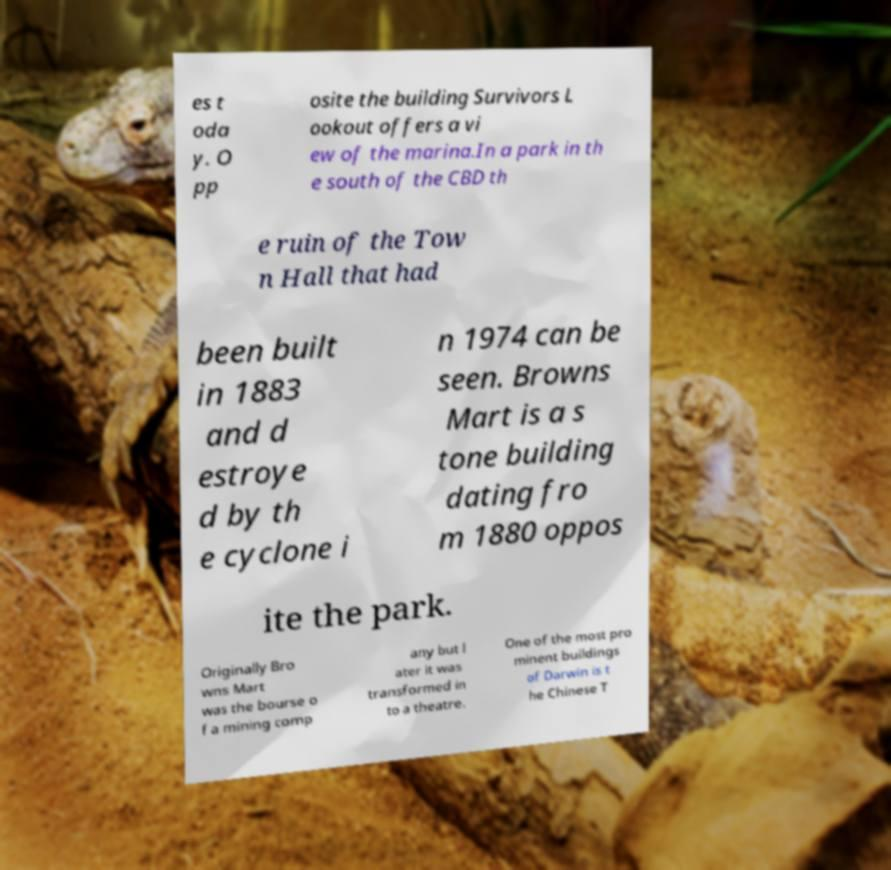I need the written content from this picture converted into text. Can you do that? es t oda y. O pp osite the building Survivors L ookout offers a vi ew of the marina.In a park in th e south of the CBD th e ruin of the Tow n Hall that had been built in 1883 and d estroye d by th e cyclone i n 1974 can be seen. Browns Mart is a s tone building dating fro m 1880 oppos ite the park. Originally Bro wns Mart was the bourse o f a mining comp any but l ater it was transformed in to a theatre. One of the most pro minent buildings of Darwin is t he Chinese T 